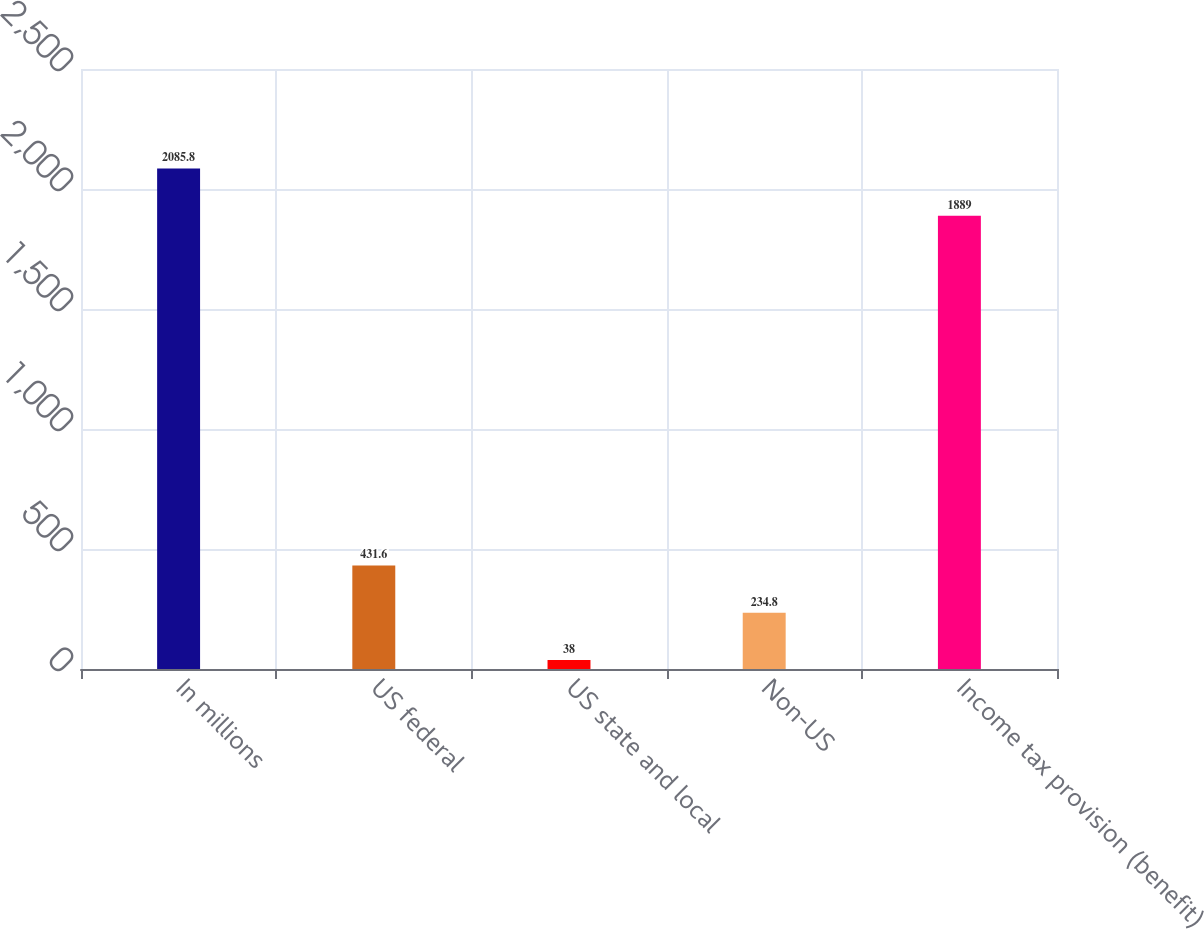Convert chart. <chart><loc_0><loc_0><loc_500><loc_500><bar_chart><fcel>In millions<fcel>US federal<fcel>US state and local<fcel>Non-US<fcel>Income tax provision (benefit)<nl><fcel>2085.8<fcel>431.6<fcel>38<fcel>234.8<fcel>1889<nl></chart> 